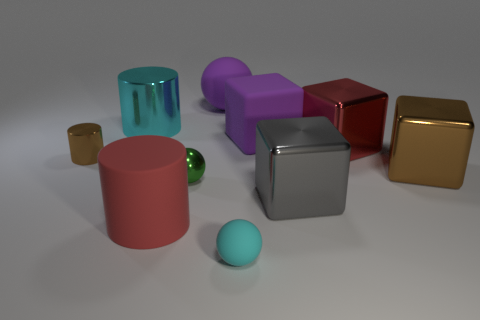Can you tell me which objects are cubes in this image? In the image, there are two objects that are cubes: a metallic looking one with what appears to be a reflective surface, and another cube that has a gold-like color with a matte finish. 